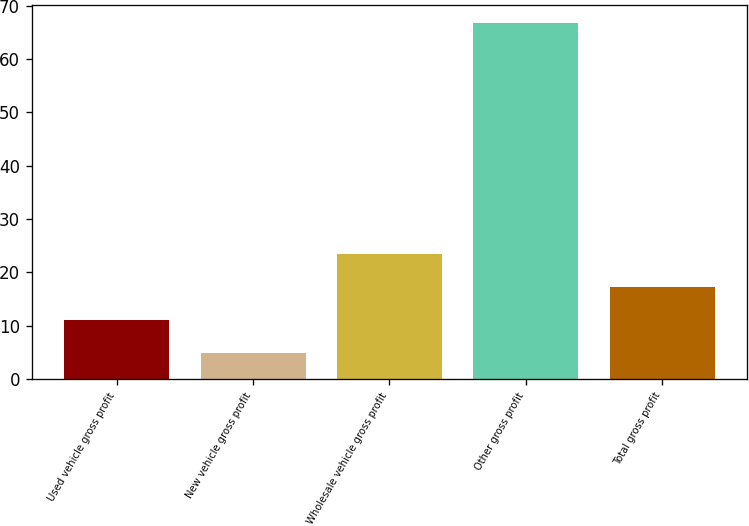<chart> <loc_0><loc_0><loc_500><loc_500><bar_chart><fcel>Used vehicle gross profit<fcel>New vehicle gross profit<fcel>Wholesale vehicle gross profit<fcel>Other gross profit<fcel>Total gross profit<nl><fcel>11.09<fcel>4.9<fcel>23.47<fcel>66.8<fcel>17.28<nl></chart> 